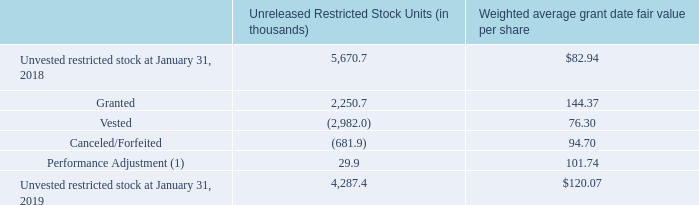Restricted Stock Units:
A summary of restricted stock activity for the fiscal year ended January 31, 2019 is as follows:
(1) Based on Autodesk's financial results and relative total stockholder return for the fiscal 2018 performance period. The performance stock units were attained at rates ranging from 90.0% to 117.6% of the target award.
For the restricted stock granted during fiscal years ended January 31, 2019, 2018, and 2017, the weighted average grant date fair values were $144.37, $106.55, and $65.95, respectively. The fair values of the shares vested during fiscal years ended January 31, 2019, 2018, and 2017 were $425.4 million, $399.7 million, and $232.2 million, respectively.
During the fiscal year ended January 31, 2019, Autodesk granted 2.1 million restricted stock units. Restricted stock units
vest over periods ranging from immediately upon grant to a pre-determined date that is typically within three years from the
date of grant. Restricted stock units are not considered outstanding stock at the time of grant, as the holders of these units are
not entitled to any of the rights of a stockholder, including voting rights. The fair value of the restricted stock units is expensed
ratably over the vesting period. Autodesk recorded stock-based compensation expense related to restricted stock units of $189.3
million, $202.1 million, and $173.0 million during fiscal years ended January 31, 2019, 2018, and 2017, respectively. As of
January 31, 2019, total compensation cost not yet recognized of $364.5 million related to non-vested awards is expected to be
recognized over a weighted average period of 1.76 years. At January 31, 2019, the number of restricted stock units granted but
unvested was 3.9 million.
During the fiscal year ended January 31, 2019, Autodesk granted 0.2 million performance stock units for which the ultimate number of shares earned is determined based on the achievement of performance criteria at the end of the stated service and performance period. The performance criteria for the performance stock units are based on Annualized Recurring Revenue ("ARR") and free cash flow per share goals adopted by the Compensation and Human Resources Committee, as well as total stockholder return compared against companies in the S&P Computer Software Select Index or the S&P North American Technology Software Index ("Relative TSR"). These performance stock units vest over a three-year period and have the following vesting schedule:
Up to one third of the performance stock units may vest following year one, depending upon the achievement of the performance criteria for fiscal 2019 as well as 1-year Relative TSR (covering year one).
Up to one third of the performance stock units may vest following year two, depending upon the achievement of the performance criteria for year two as well as 2-year Relative TSR (covering years one and two).
Up to one third of the performance stock units may vest following year three, depending upon the achievement of the performance criteria for year three as well as 3-year Relative TSR (covering years one, two and three).
Performance stock units are not considered outstanding stock at the time of grant, as the holders of these units are not entitled to any of the rights of a stockholder, including voting rights. Autodesk has determined the grant-date fair value for these awards using the stock price on the date of grant or if the awards are subject to a market condition, a Monte Carlo simulation model. The fair value of the performance stock units is expensed using the accelerated attribution over the vesting period. Autodesk recorded stock-based compensation expense related to performance stock units of $28.6 million, $33.7 million, and $22.9 million during fiscal years ended January 31, 2019, 2018, and 2017 respectively. As of January 31, 2019, total compensation cost not yet recognized of $5.6 million related to unvested performance stock units, is expected to be recognized over a weighted average period of 0.81 years. At January 31, 2019, the number of performance stock units granted but unvested was 0.4 million.
How many restricted stock units did Autodesk grant in the fiscal year ended 31 January, 2019? 2.1 million. What is the performance criteria for the performance stock units? The performance criteria for the performance stock units are based on annualized recurring revenue ("arr") and free cash flow per share goals adopted by the compensation and human resources committee, as well as total stockholder return compared against companies in the s&p computer software select index or the s&p north american technology software index ("relative tsr"). How many units of unvested restricted stock were there as of January 31, 2019?
Answer scale should be: thousand. 4,287.4. What is the difference in the units of unvested restricted stock for 2019 and 2018?
Answer scale should be: thousand. 5,670.7-4,287.4
Answer: 1383.3. What is the average fair value of the shares vested for the period from 2017 to 2019?
Answer scale should be: million. (425.4+399.7+232.2)/3
Answer: 352.43. What is the average fair value of the shares vested for the period from 2017 to 2019??
Answer scale should be: million. (425.4+399.7+232.2)/3 
Answer: 352.43. 